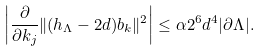Convert formula to latex. <formula><loc_0><loc_0><loc_500><loc_500>\left | \frac { \partial } { \partial k _ { j } } \| ( h _ { \Lambda } - 2 d ) b _ { k } \| ^ { 2 } \right | \leq \alpha 2 ^ { 6 } d ^ { 4 } | \partial \Lambda | .</formula> 